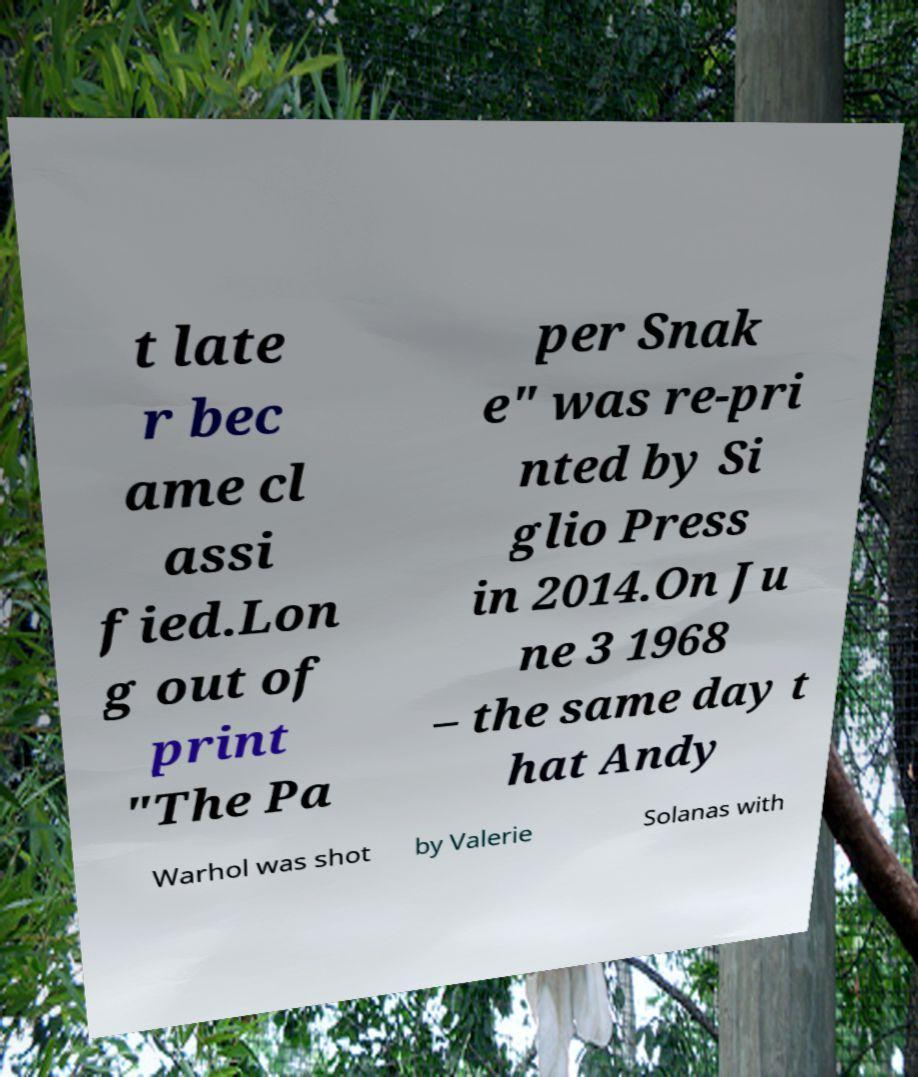Can you read and provide the text displayed in the image?This photo seems to have some interesting text. Can you extract and type it out for me? t late r bec ame cl assi fied.Lon g out of print "The Pa per Snak e" was re-pri nted by Si glio Press in 2014.On Ju ne 3 1968 – the same day t hat Andy Warhol was shot by Valerie Solanas with 